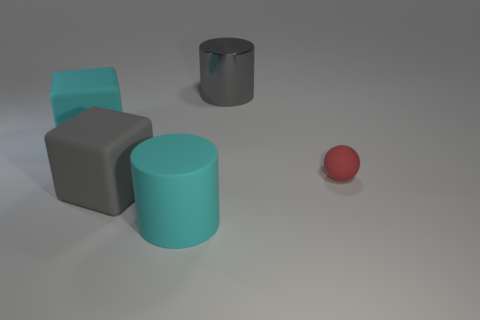Add 2 blue matte blocks. How many objects exist? 7 Subtract all cylinders. How many objects are left? 3 Subtract 0 cyan balls. How many objects are left? 5 Subtract all red balls. Subtract all gray cylinders. How many objects are left? 3 Add 2 big gray things. How many big gray things are left? 4 Add 1 gray matte objects. How many gray matte objects exist? 2 